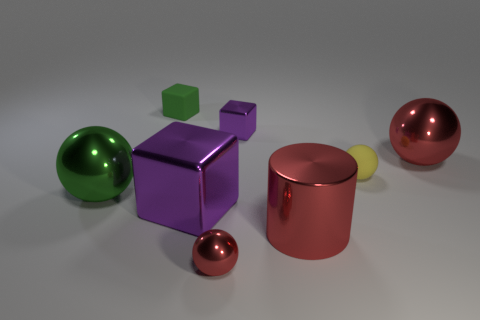What number of objects are behind the big shiny cylinder and in front of the rubber block?
Give a very brief answer. 5. There is a big red metallic object behind the big green sphere; is its shape the same as the tiny purple thing?
Offer a very short reply. No. There is a red ball that is the same size as the green ball; what material is it?
Give a very brief answer. Metal. Are there an equal number of cubes that are to the right of the yellow thing and large spheres that are in front of the red cylinder?
Provide a succinct answer. Yes. There is a green thing on the right side of the large thing left of the big purple metal cube; what number of green spheres are to the right of it?
Your answer should be compact. 0. There is a big cylinder; is its color the same as the matte object that is to the left of the red cylinder?
Provide a succinct answer. No. There is a green sphere that is made of the same material as the large purple object; what size is it?
Your answer should be very brief. Large. Are there more big green metallic things behind the large purple shiny cube than small green rubber objects?
Keep it short and to the point. No. There is a green thing in front of the tiny rubber object that is behind the big object that is behind the green sphere; what is it made of?
Make the answer very short. Metal. Is the yellow sphere made of the same material as the red object to the left of the big cylinder?
Offer a very short reply. No. 